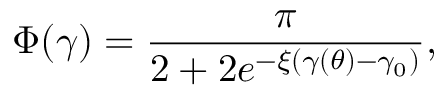<formula> <loc_0><loc_0><loc_500><loc_500>\Phi ( \gamma ) = \frac { \pi } { 2 + 2 e ^ { - \xi ( \gamma ( \theta ) - \gamma _ { 0 } ) } } ,</formula> 